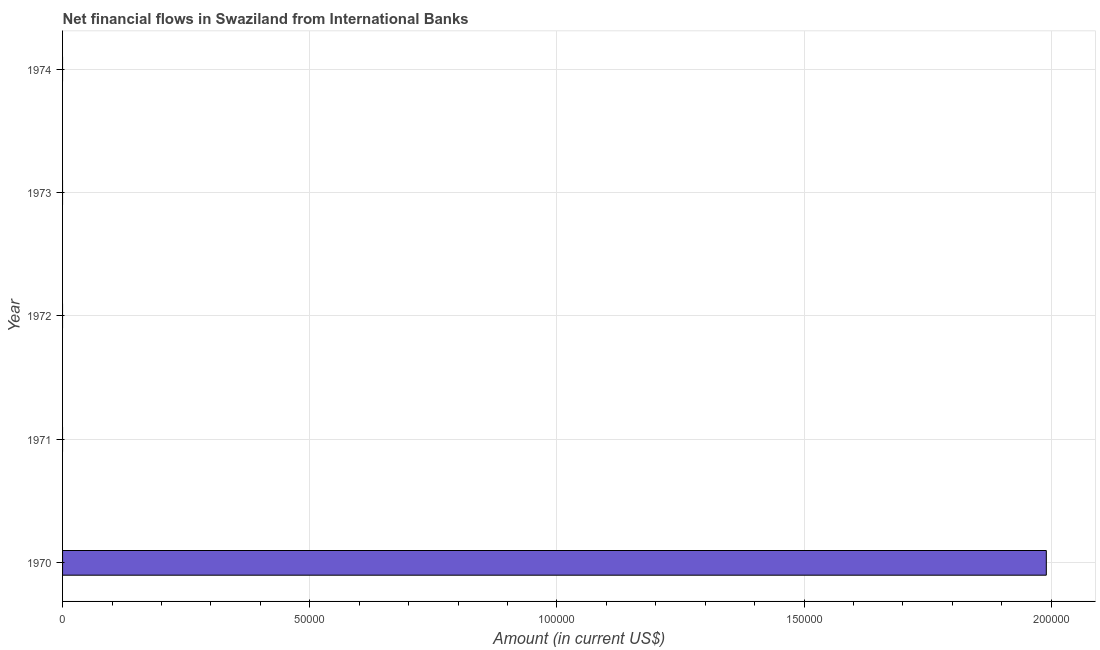Does the graph contain any zero values?
Make the answer very short. Yes. What is the title of the graph?
Offer a terse response. Net financial flows in Swaziland from International Banks. What is the net financial flows from ibrd in 1974?
Give a very brief answer. 0. Across all years, what is the maximum net financial flows from ibrd?
Ensure brevity in your answer.  1.99e+05. Across all years, what is the minimum net financial flows from ibrd?
Make the answer very short. 0. What is the sum of the net financial flows from ibrd?
Give a very brief answer. 1.99e+05. What is the average net financial flows from ibrd per year?
Make the answer very short. 3.98e+04. What is the difference between the highest and the lowest net financial flows from ibrd?
Your answer should be compact. 1.99e+05. In how many years, is the net financial flows from ibrd greater than the average net financial flows from ibrd taken over all years?
Provide a succinct answer. 1. How many bars are there?
Give a very brief answer. 1. Are all the bars in the graph horizontal?
Provide a succinct answer. Yes. What is the difference between two consecutive major ticks on the X-axis?
Make the answer very short. 5.00e+04. What is the Amount (in current US$) in 1970?
Give a very brief answer. 1.99e+05. What is the Amount (in current US$) in 1972?
Give a very brief answer. 0. 